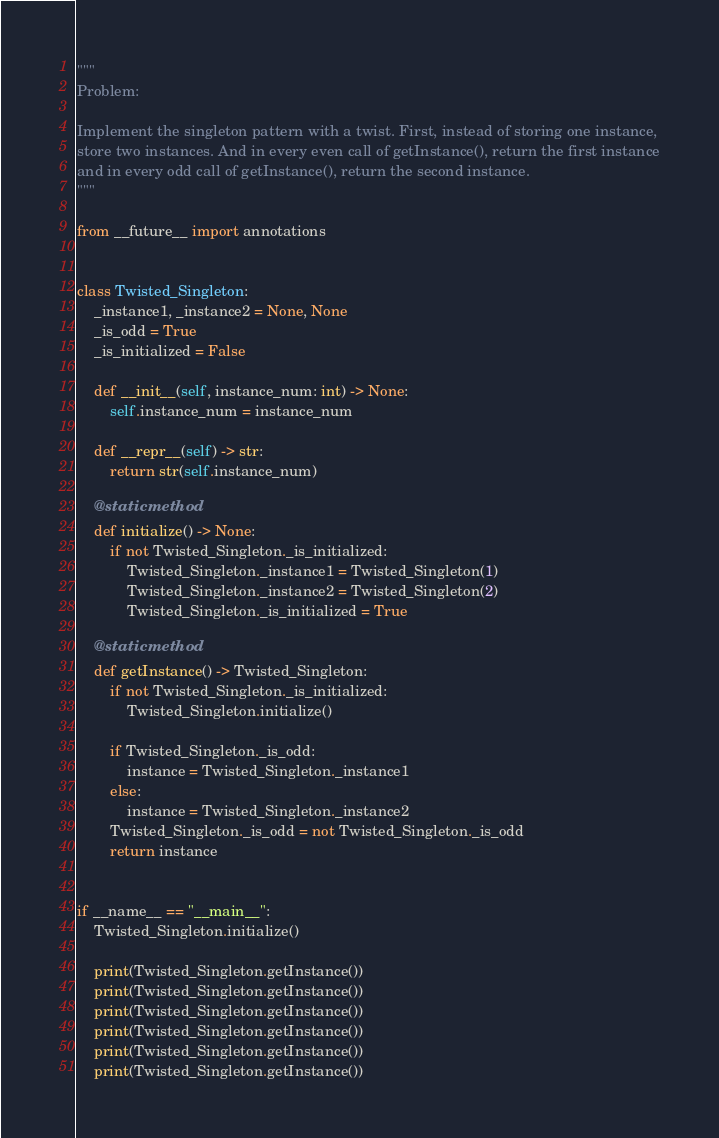Convert code to text. <code><loc_0><loc_0><loc_500><loc_500><_Python_>"""
Problem:

Implement the singleton pattern with a twist. First, instead of storing one instance,
store two instances. And in every even call of getInstance(), return the first instance
and in every odd call of getInstance(), return the second instance.
"""

from __future__ import annotations


class Twisted_Singleton:
    _instance1, _instance2 = None, None
    _is_odd = True
    _is_initialized = False

    def __init__(self, instance_num: int) -> None:
        self.instance_num = instance_num

    def __repr__(self) -> str:
        return str(self.instance_num)

    @staticmethod
    def initialize() -> None:
        if not Twisted_Singleton._is_initialized:
            Twisted_Singleton._instance1 = Twisted_Singleton(1)
            Twisted_Singleton._instance2 = Twisted_Singleton(2)
            Twisted_Singleton._is_initialized = True

    @staticmethod
    def getInstance() -> Twisted_Singleton:
        if not Twisted_Singleton._is_initialized:
            Twisted_Singleton.initialize()

        if Twisted_Singleton._is_odd:
            instance = Twisted_Singleton._instance1
        else:
            instance = Twisted_Singleton._instance2
        Twisted_Singleton._is_odd = not Twisted_Singleton._is_odd
        return instance


if __name__ == "__main__":
    Twisted_Singleton.initialize()

    print(Twisted_Singleton.getInstance())
    print(Twisted_Singleton.getInstance())
    print(Twisted_Singleton.getInstance())
    print(Twisted_Singleton.getInstance())
    print(Twisted_Singleton.getInstance())
    print(Twisted_Singleton.getInstance())
</code> 